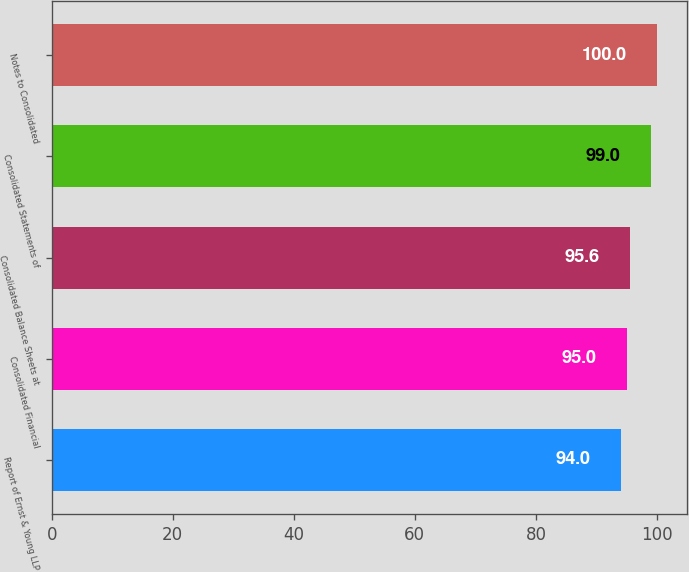Convert chart to OTSL. <chart><loc_0><loc_0><loc_500><loc_500><bar_chart><fcel>Report of Ernst & Young LLP<fcel>Consolidated Financial<fcel>Consolidated Balance Sheets at<fcel>Consolidated Statements of<fcel>Notes to Consolidated<nl><fcel>94<fcel>95<fcel>95.6<fcel>99<fcel>100<nl></chart> 